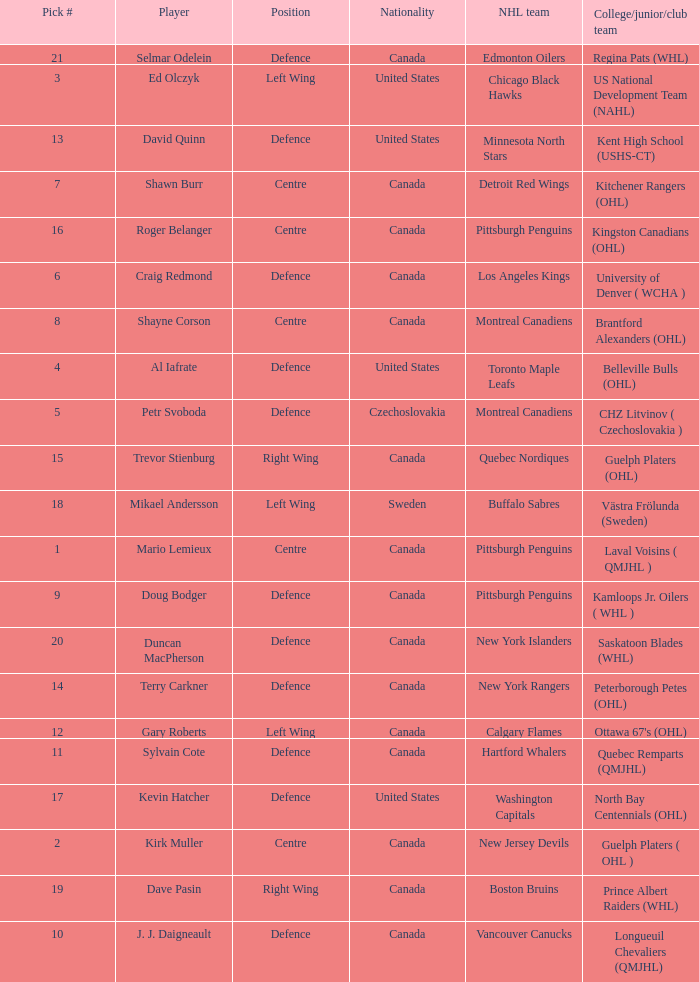Help me parse the entirety of this table. {'header': ['Pick #', 'Player', 'Position', 'Nationality', 'NHL team', 'College/junior/club team'], 'rows': [['21', 'Selmar Odelein', 'Defence', 'Canada', 'Edmonton Oilers', 'Regina Pats (WHL)'], ['3', 'Ed Olczyk', 'Left Wing', 'United States', 'Chicago Black Hawks', 'US National Development Team (NAHL)'], ['13', 'David Quinn', 'Defence', 'United States', 'Minnesota North Stars', 'Kent High School (USHS-CT)'], ['7', 'Shawn Burr', 'Centre', 'Canada', 'Detroit Red Wings', 'Kitchener Rangers (OHL)'], ['16', 'Roger Belanger', 'Centre', 'Canada', 'Pittsburgh Penguins', 'Kingston Canadians (OHL)'], ['6', 'Craig Redmond', 'Defence', 'Canada', 'Los Angeles Kings', 'University of Denver ( WCHA )'], ['8', 'Shayne Corson', 'Centre', 'Canada', 'Montreal Canadiens', 'Brantford Alexanders (OHL)'], ['4', 'Al Iafrate', 'Defence', 'United States', 'Toronto Maple Leafs', 'Belleville Bulls (OHL)'], ['5', 'Petr Svoboda', 'Defence', 'Czechoslovakia', 'Montreal Canadiens', 'CHZ Litvinov ( Czechoslovakia )'], ['15', 'Trevor Stienburg', 'Right Wing', 'Canada', 'Quebec Nordiques', 'Guelph Platers (OHL)'], ['18', 'Mikael Andersson', 'Left Wing', 'Sweden', 'Buffalo Sabres', 'Västra Frölunda (Sweden)'], ['1', 'Mario Lemieux', 'Centre', 'Canada', 'Pittsburgh Penguins', 'Laval Voisins ( QMJHL )'], ['9', 'Doug Bodger', 'Defence', 'Canada', 'Pittsburgh Penguins', 'Kamloops Jr. Oilers ( WHL )'], ['20', 'Duncan MacPherson', 'Defence', 'Canada', 'New York Islanders', 'Saskatoon Blades (WHL)'], ['14', 'Terry Carkner', 'Defence', 'Canada', 'New York Rangers', 'Peterborough Petes (OHL)'], ['12', 'Gary Roberts', 'Left Wing', 'Canada', 'Calgary Flames', "Ottawa 67's (OHL)"], ['11', 'Sylvain Cote', 'Defence', 'Canada', 'Hartford Whalers', 'Quebec Remparts (QMJHL)'], ['17', 'Kevin Hatcher', 'Defence', 'United States', 'Washington Capitals', 'North Bay Centennials (OHL)'], ['2', 'Kirk Muller', 'Centre', 'Canada', 'New Jersey Devils', 'Guelph Platers ( OHL )'], ['19', 'Dave Pasin', 'Right Wing', 'Canada', 'Boston Bruins', 'Prince Albert Raiders (WHL)'], ['10', 'J. J. Daigneault', 'Defence', 'Canada', 'Vancouver Canucks', 'Longueuil Chevaliers (QMJHL)']]} What daft pick number is the player coming from Regina Pats (WHL)? 21.0. 